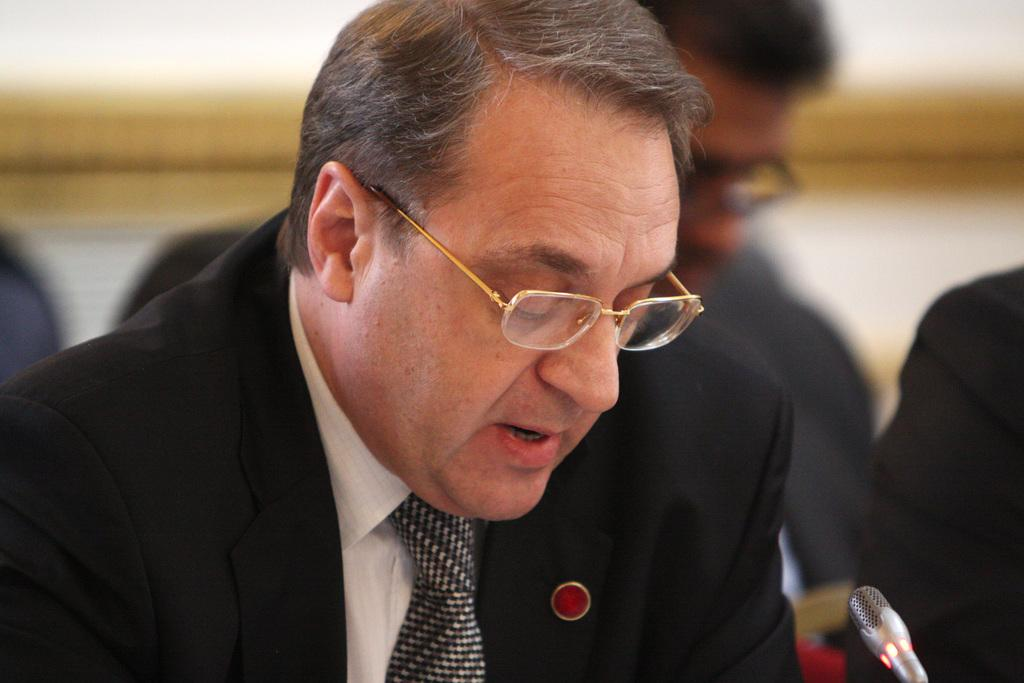What is the man in the image wearing? The man in the image is wearing glasses. What object is present in the image that is typically used for amplifying sound? There is a microphone in the image. What can be seen in the background of the image? There are persons and a wall visible in the background of the image. What type of payment is being made in the image? There is no payment being made in the image; it features a man with glasses and a microphone. What is the man doing with his mouth in the image? The man's mouth is not visible in the image, so it cannot be determined what he might be doing with it. 